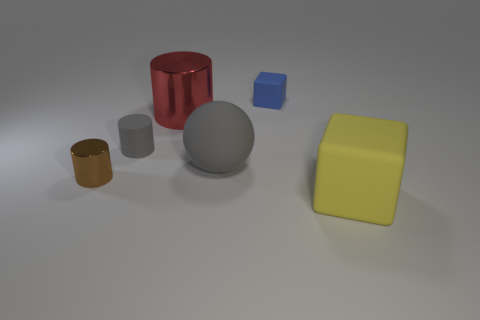Is there anything else that is the same shape as the large gray object?
Your response must be concise. No. What is the material of the cube that is the same size as the gray sphere?
Ensure brevity in your answer.  Rubber. How many other things are the same material as the small gray object?
Your answer should be compact. 3. How many balls are in front of the tiny gray cylinder?
Give a very brief answer. 1. How many cubes are blue matte things or large things?
Provide a short and direct response. 2. There is a cylinder that is behind the gray matte ball and to the left of the big metallic cylinder; what is its size?
Your answer should be compact. Small. What number of other objects are there of the same color as the matte sphere?
Your answer should be compact. 1. Do the tiny brown object and the block behind the large block have the same material?
Your response must be concise. No. What number of things are either metallic things that are in front of the big red cylinder or gray rubber things?
Give a very brief answer. 3. There is a object that is to the right of the big matte sphere and in front of the big gray matte sphere; what shape is it?
Give a very brief answer. Cube. 